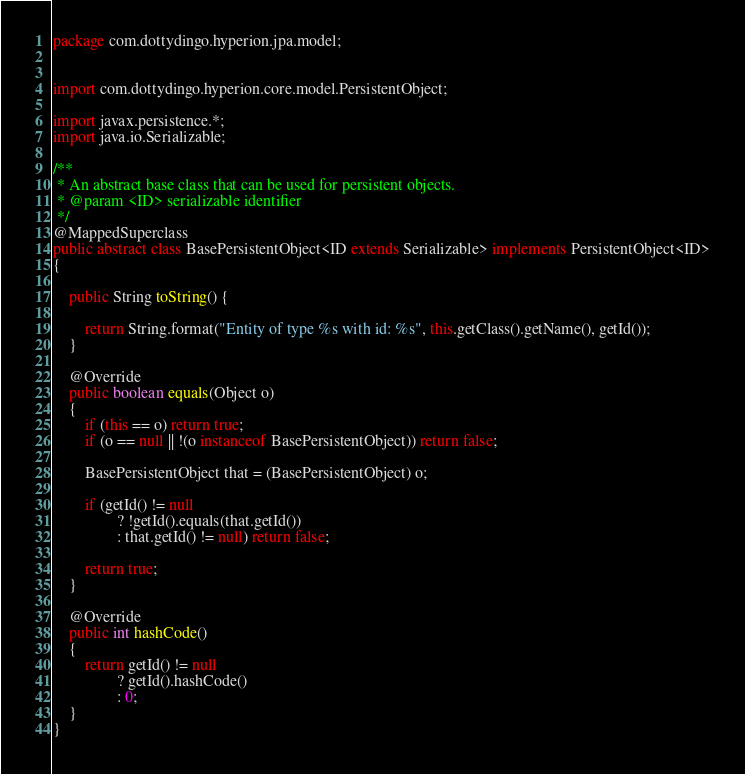Convert code to text. <code><loc_0><loc_0><loc_500><loc_500><_Java_>package com.dottydingo.hyperion.jpa.model;


import com.dottydingo.hyperion.core.model.PersistentObject;

import javax.persistence.*;
import java.io.Serializable;

/**
 * An abstract base class that can be used for persistent objects.
 * @param <ID> serializable identifier
 */
@MappedSuperclass
public abstract class BasePersistentObject<ID extends Serializable> implements PersistentObject<ID>
{

    public String toString() {

        return String.format("Entity of type %s with id: %s", this.getClass().getName(), getId());
    }

    @Override
    public boolean equals(Object o)
    {
        if (this == o) return true;
        if (o == null || !(o instanceof BasePersistentObject)) return false;

        BasePersistentObject that = (BasePersistentObject) o;

        if (getId() != null
                ? !getId().equals(that.getId())
                : that.getId() != null) return false;

        return true;
    }

    @Override
    public int hashCode()
    {
        return getId() != null
                ? getId().hashCode()
                : 0;
    }
}
</code> 